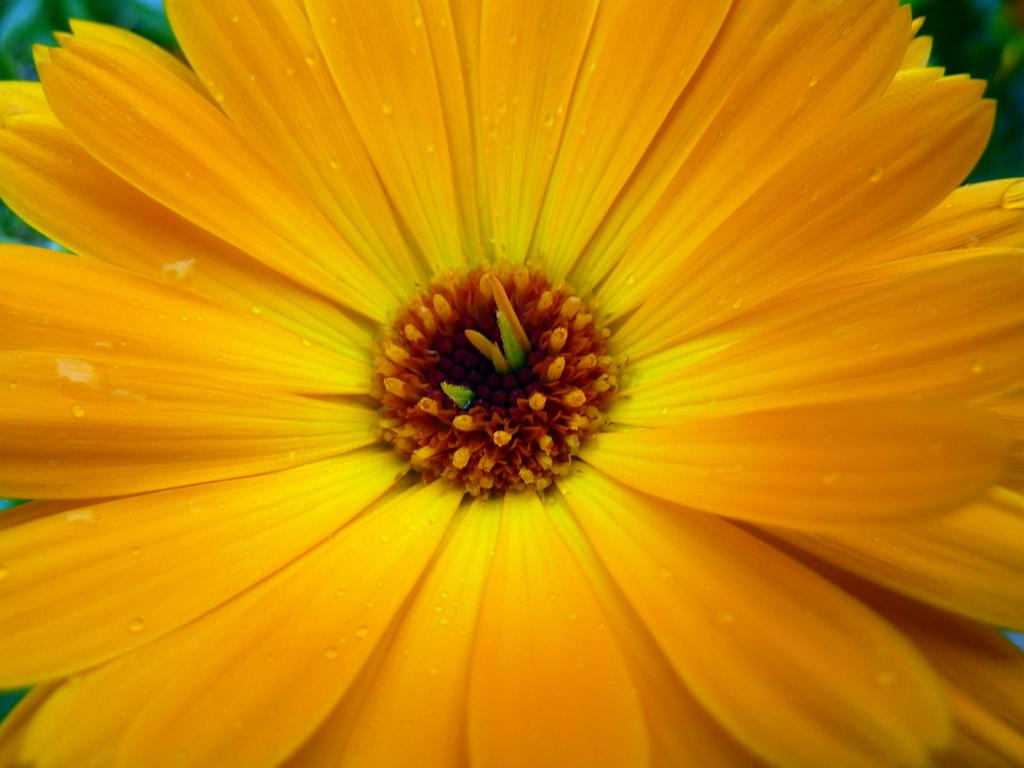What type of flower is present in the image? There is a yellow color flower in the image. Can you see any ducks swimming in the water near the flower in the image? There is no water or ducks present in the image; it only features a yellow color flower. 